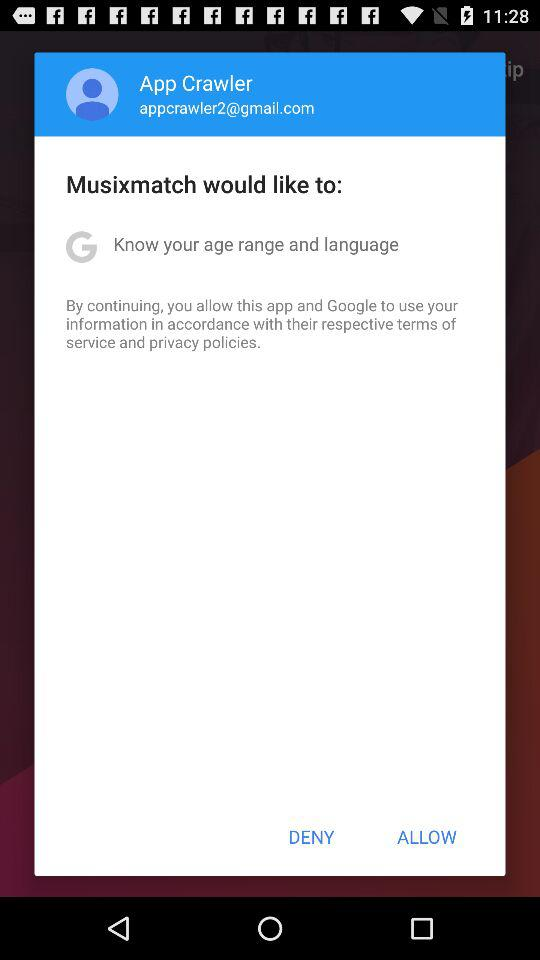What is the name of the application? The name of the application is "Musixmatch". 